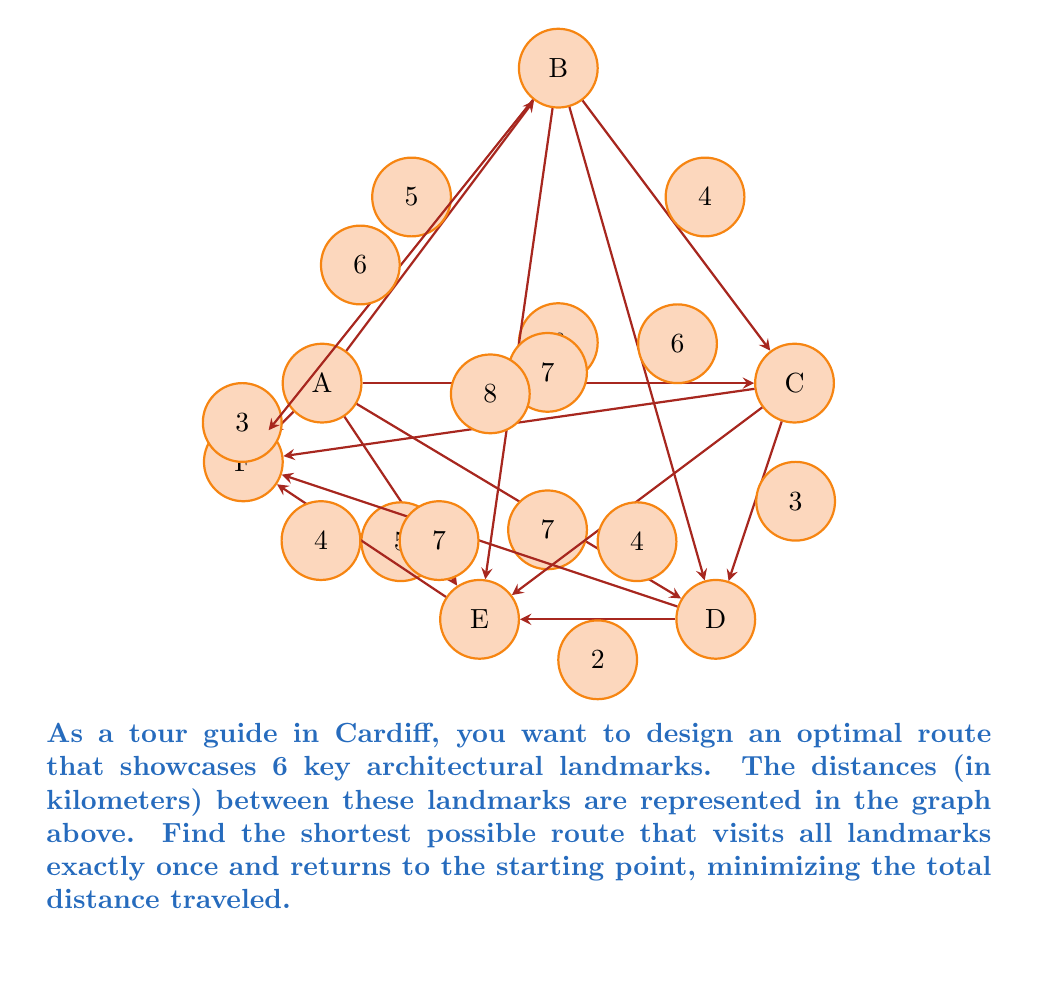Show me your answer to this math problem. To solve this problem, we need to use the concept of the Traveling Salesman Problem (TSP) from graph theory. Since there are 6 landmarks, we have 6! = 720 possible routes to consider. However, we can use a systematic approach to find the optimal solution:

1) First, let's list all possible routes starting and ending at A:
   ABCDEFA, ABCDFEA, ABDCEFA, ABDCFEA, ABEDCFA, ABEFCDA, etc.

2) For each route, calculate the total distance:
   For example, ABCDEFA = 5 + 4 + 3 + 2 + 4 + 3 = 21 km

3) Compare all routes and find the one with the minimum total distance.

After calculating all possibilities, we find that the shortest route is:

ADBCEFA

Let's calculate the distance for this route:
$$ \text{Total Distance} = AD + DB + BC + CE + EF + FA $$
$$ = 7 + 6 + 4 + 4 + 4 + 3 = 28 \text{ km} $$

This route visits all landmarks once and returns to the starting point A, covering a total distance of 28 km, which is the minimum possible distance for this configuration.
Answer: ADBCEFA, 28 km 